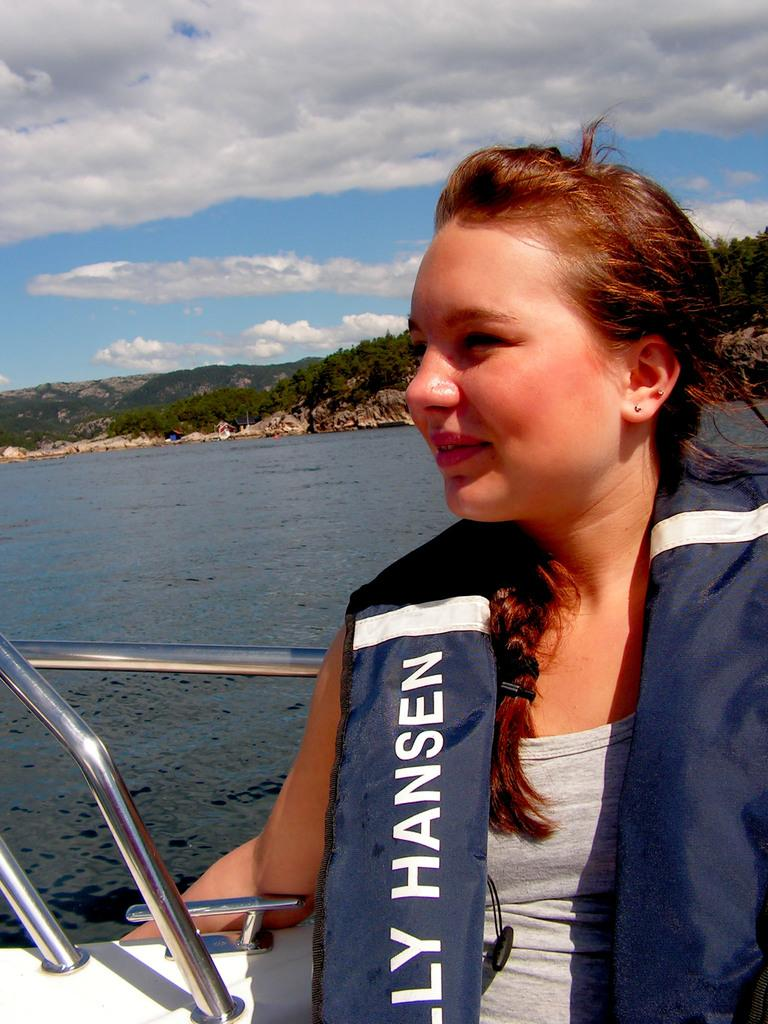What is the woman in the image doing? The woman is sitting in a boat in the image. What is the primary element surrounding the boat? There is water visible in the image. What can be seen in the distance behind the boat? There are hills in the background of the image. What is the condition of the sky in the image? The sky is clear and visible at the top of the image. What type of tank can be seen in the image? There is no tank present in the image; it features a woman sitting in a boat on water with hills in the background and a clear sky. Is the queen present in the image? There is no queen depicted in the image. 